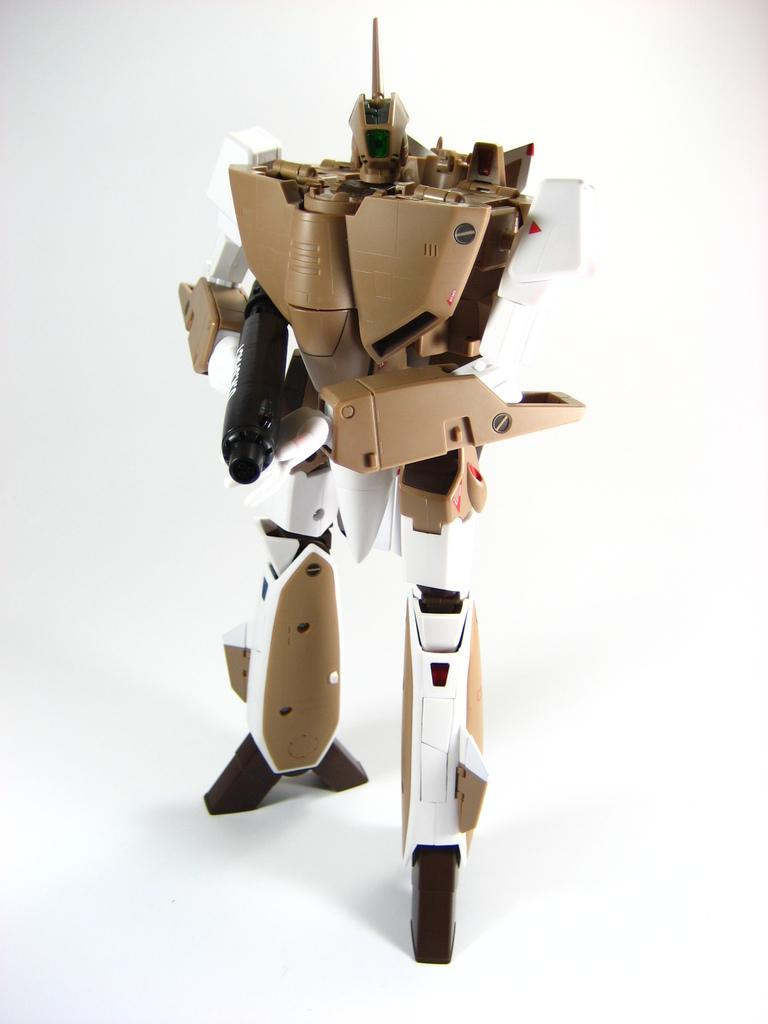What color is the background of the image? The background of the image is white. What is the main subject in the middle of the image? There is a robot in the middle of the image. What type of leaf is being used by the robot in the image? There is no leaf present in the image; it features a robot in a white background. 